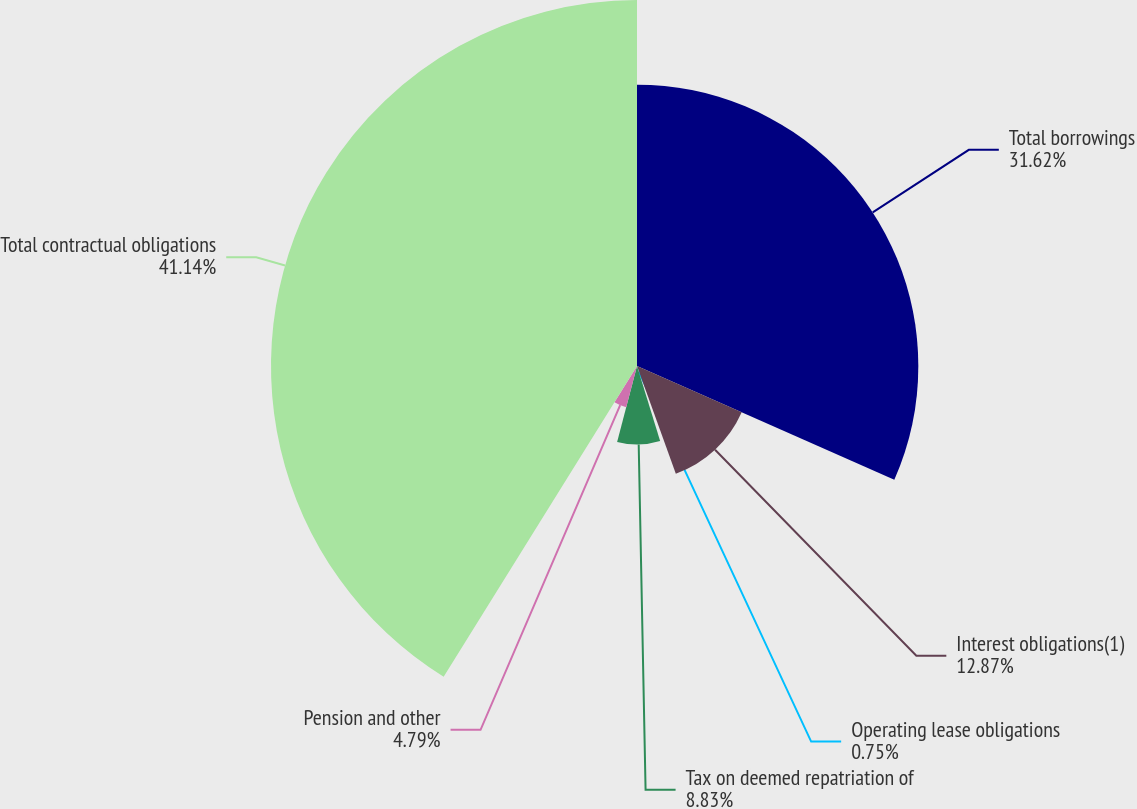Convert chart. <chart><loc_0><loc_0><loc_500><loc_500><pie_chart><fcel>Total borrowings<fcel>Interest obligations(1)<fcel>Operating lease obligations<fcel>Tax on deemed repatriation of<fcel>Pension and other<fcel>Total contractual obligations<nl><fcel>31.63%<fcel>12.87%<fcel>0.75%<fcel>8.83%<fcel>4.79%<fcel>41.15%<nl></chart> 